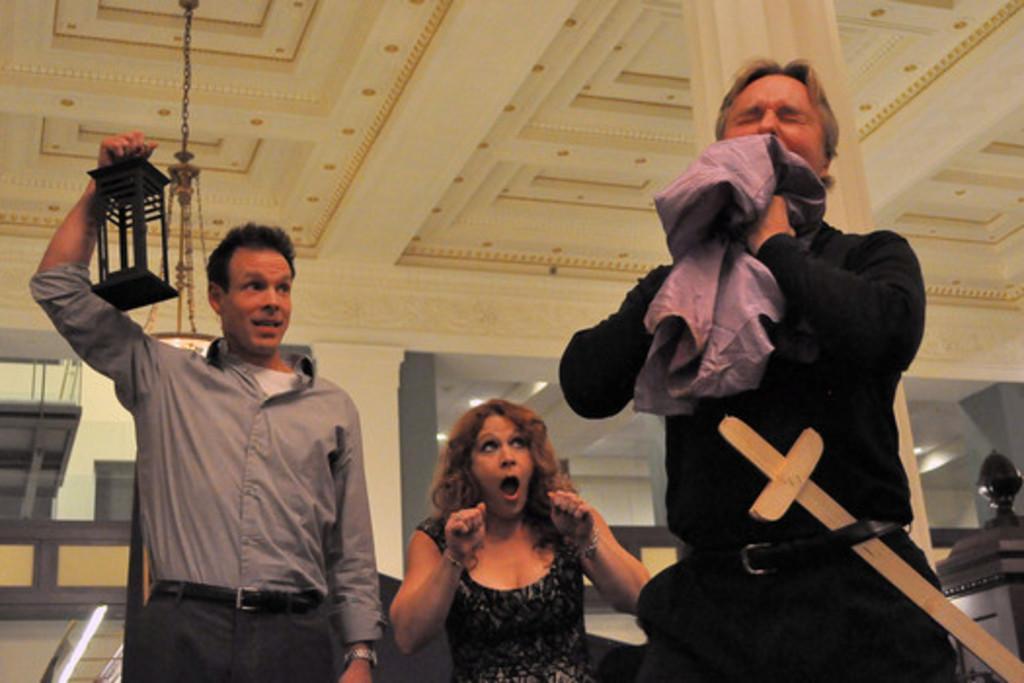How would you summarize this image in a sentence or two? In this image on the left I can see a man holding something. On the right side, I can see a man. In the middle I can see a woman. At the top I can see a light hanging on the wall. 